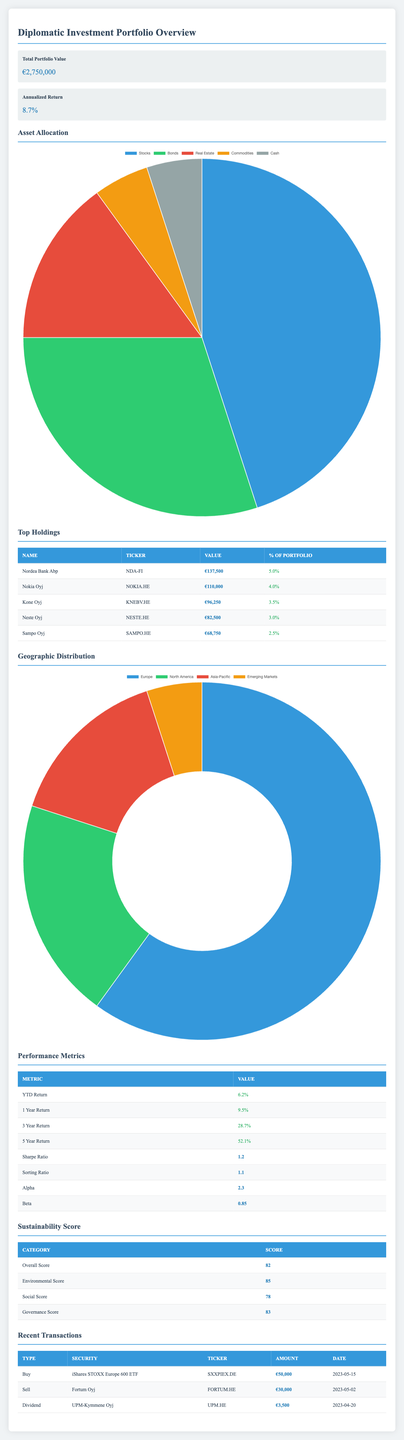What is the total value of the portfolio? The total value of the portfolio is clearly indicated at the top of the table as €2,750,000.
Answer: €2,750,000 What percentage of the portfolio is allocated to Real Estate? In the asset allocation section, Real Estate is listed with a percentage of 15%.
Answer: 15% Is the annualized return greater than 9%? The annualized return of the portfolio is 8.7%, which is less than 9%.
Answer: No What is the value of the largest holding? The largest holding is Nordea Bank Abp with a value of €137,500, as shown in the top holdings section.
Answer: €137,500 What is the total percentage of investments allocated to Bonds and Real Estate combined? The percentage allocated to Bonds is 30% and Real Estate is 15%. Their sum is 30 + 15 = 45%.
Answer: 45% Is there a transaction where €50,000 was invested? Yes, there is a recent transaction that indicates a Buy of iShares STOXX Europe 600 ETF for €50,000.
Answer: Yes What is the three-year return percentage? The three-year return is explicitly stated in the performance metrics section as 28.7%.
Answer: 28.7% Calculate the Sharpe Ratio to Sorting Ratio difference. The Sharpe Ratio is 1.2 and the Sorting Ratio is 1.1. The difference is calculated as 1.2 - 1.1 = 0.1.
Answer: 0.1 Which region has the highest percentage in the geographic distribution? Europe has the highest percentage at 60%, as indicated in the geographic distribution section.
Answer: Europe How many transactions were made in total? There are three transactions listed in the recent transactions section, which includes Buy, Sell, and Dividend types.
Answer: 3 